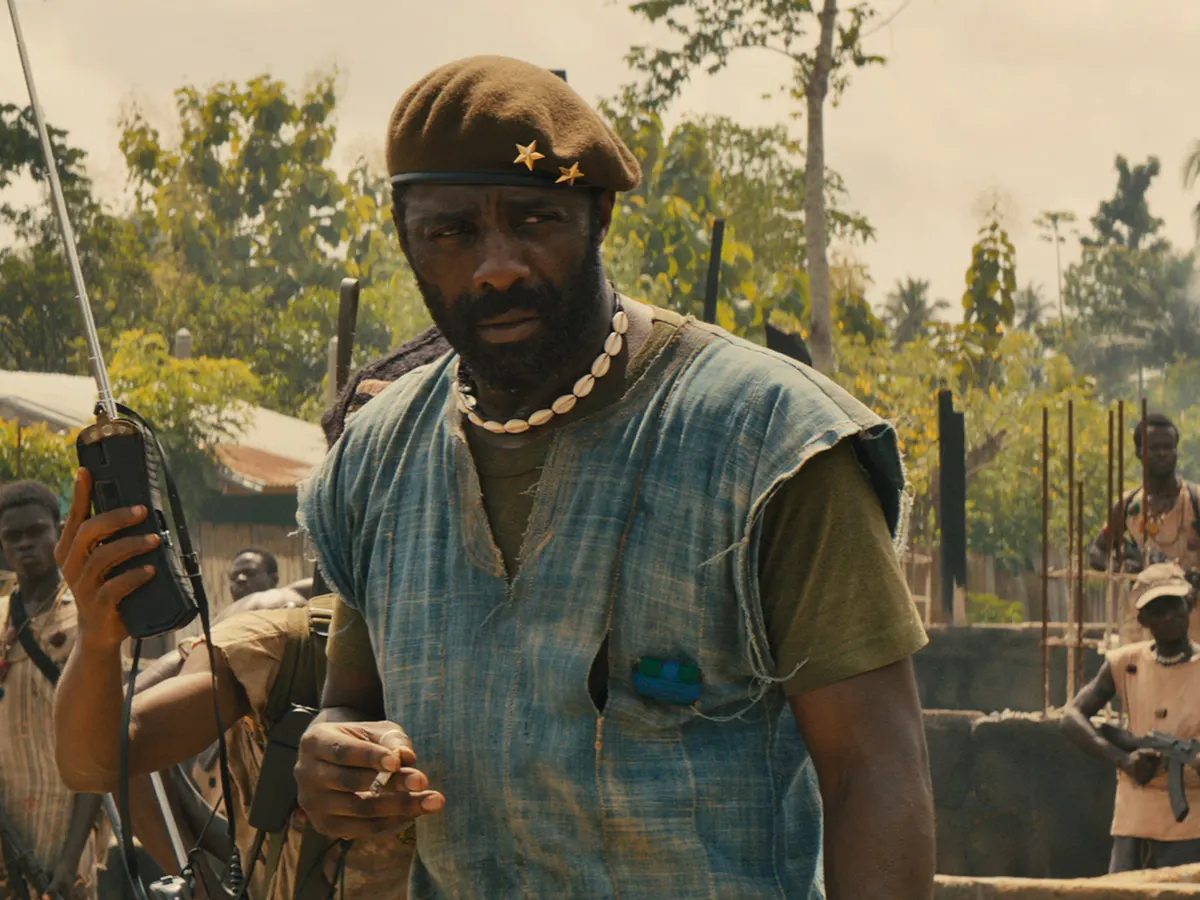Imagine this scene is part of a historical documentary. How would you narrate it? In the waning days of the civil conflict, leaders like Commandant emerged as pivotal figures in the war-torn landscapes of countless villages. Here, in this small, ravaged locale, the Commandant stands resolute, embodying both the resolve and the desperation of his people. His blue sleeveless shirt and green vest, though simple, mark him as a figure of authority. The beret with its gold star and the ever-present weaponry emphasize the gravity of his role in maintaining both order and fear. The soldiers around him, though youthful and war-worn, find some measure of direction in his commands. This scene is a microcosm of the broader struggle, where survival and power walk a tenuous line, and each day brings new battles both external and internal. 